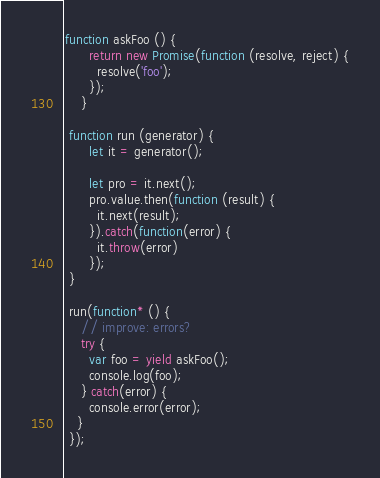<code> <loc_0><loc_0><loc_500><loc_500><_JavaScript_>function askFoo () {
      return new Promise(function (resolve, reject) {
        resolve('foo');
      });
    }
    
 function run (generator) {
      let it = generator();

      let pro = it.next();
      pro.value.then(function (result) {
        it.next(result);
      }).catch(function(error) {
        it.throw(error)
      });
 }
    
 run(function* () {
    // improve: errors?
    try {
      var foo = yield askFoo();
      console.log(foo);
    } catch(error) {
      console.error(error);
   }
 });
</code> 